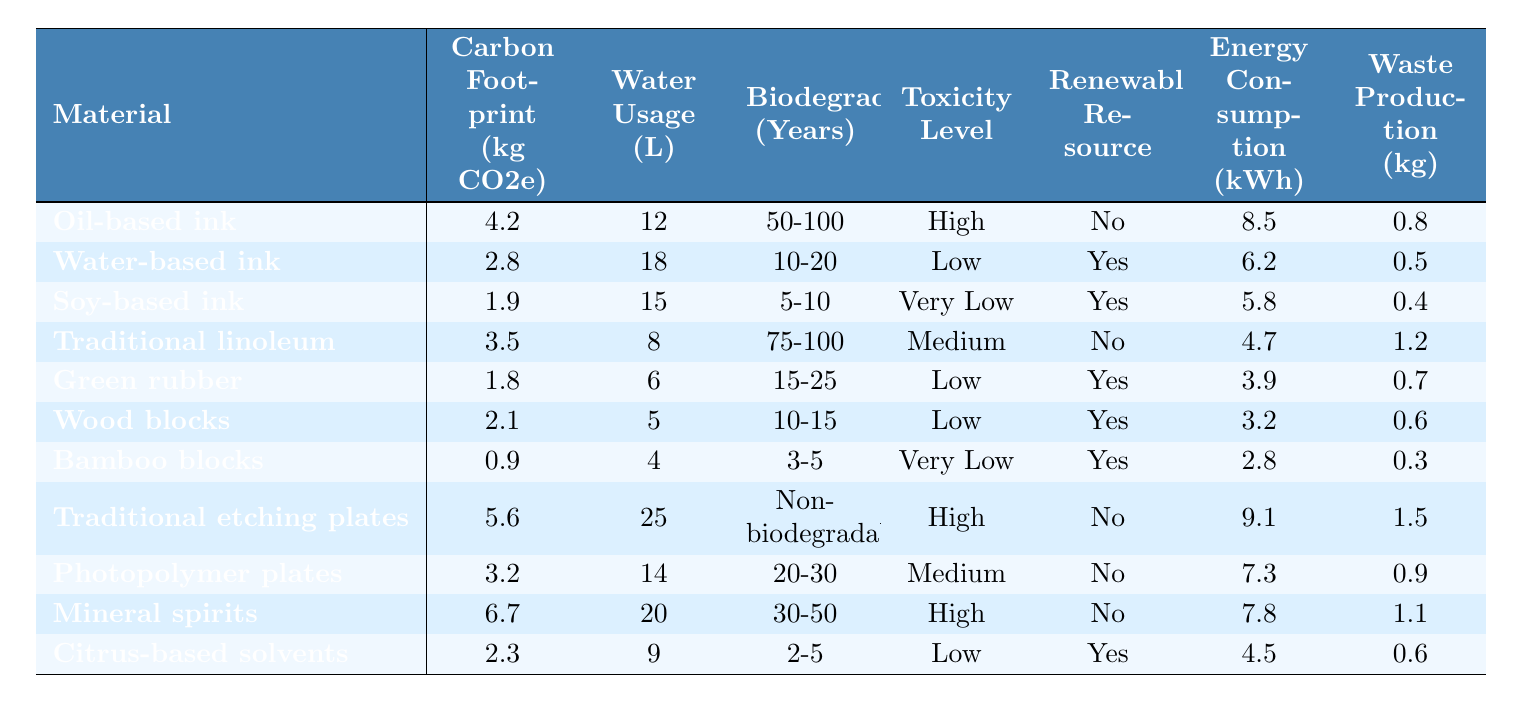What is the carbon footprint of water-based ink? From the table, the carbon footprint for water-based ink is listed as 2.8 kg CO2e.
Answer: 2.8 kg CO2e Which material has the lowest water usage? By comparing the water usage values from the table, bamboo blocks have the lowest water usage at 4 liters.
Answer: 4 liters What is the biodegradability of soy-based ink? The table indicates that soy-based ink has a biodegradability of 5-10 years.
Answer: 5-10 years Is traditional linoleum a renewable resource? The table provides that traditional linoleum is marked as "No" under the renewable resource column.
Answer: No What is the average carbon footprint of eco-friendly inks (water-based, soy-based, and citrus-based solvents)? The carbon footprints of eco-friendly inks are 2.8 (water-based) + 1.9 (soy-based) + 2.3 (citrus-based) = 7.0 kg CO2e. There are three eco-friendly inks, so the average is 7.0 / 3 = 2.33 kg CO2e.
Answer: 2.33 kg CO2e Which material has the highest energy consumption? Reviewing the table, mineral spirits have the highest energy consumption of 7.8 kWh.
Answer: 7.8 kWh How many materials have a low toxicity level? The table shows that water-based ink, green rubber, wood blocks, and citrus-based solvents are classified as having low toxicity, totaling four materials.
Answer: 4 materials What is the difference in waste production between oil-based ink and bamboo blocks? The waste production for oil-based ink is 0.8 kg, while for bamboo blocks, it is 0.3 kg. The difference is calculated as 0.8 - 0.3 = 0.5 kg.
Answer: 0.5 kg Which materials are non-biodegradable? Traditional etching plates are indicated as non-biodegradable according to the table.
Answer: Traditional etching plates What is the total water usage for all types of printmaking materials? Summing up the water usage values (12 + 18 + 15 + 8 + 6 + 5 + 4 + 25 + 14 + 20 + 9) gives a total of 132 liters.
Answer: 132 liters 